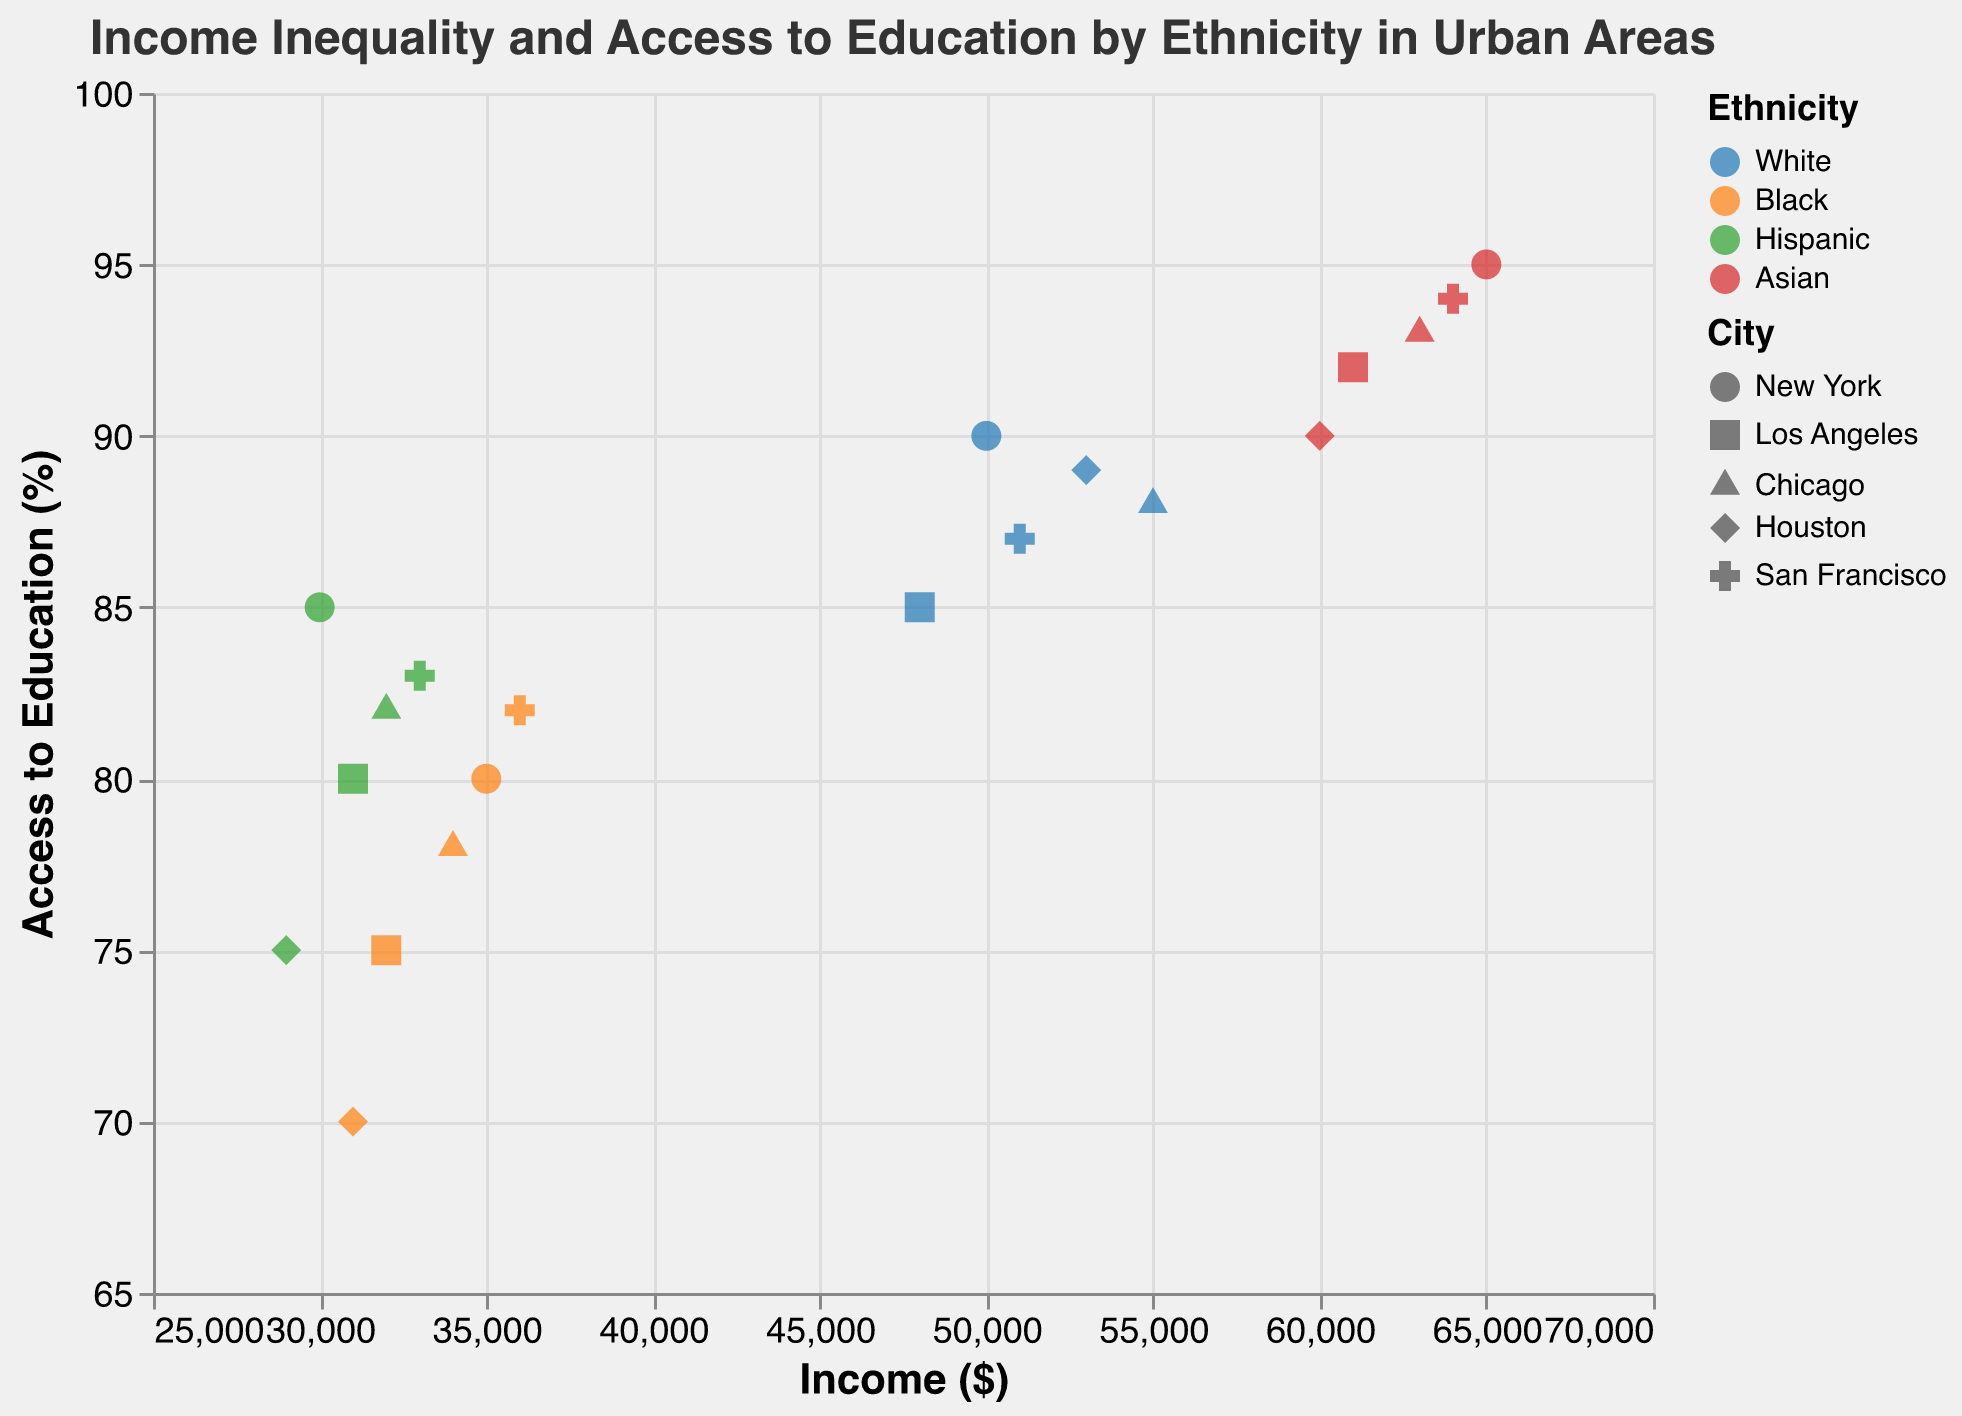What is the title of the figure? The title of the figure is usually displayed at the top and summarizes the content of the chart. By looking at the top of the figure, we can see the title.
Answer: Income Inequality and Access to Education by Ethnicity in Urban Areas How many data points are there in total? Each point on the scatter plot represents a data point. By counting all such points, we can determine the total number.
Answer: 20 Which ethnicity has the highest income in New York? To find this, look at the points representing different ethnicities in New York. Compare the income values on the X-axis to see which is the highest.
Answer: Asian What is the average Access to Education (%) for Black ethnicity across all cities? First, locate all points for Black ethnicity. Then, sum up their Access to Education (%) values and divide by the number of points (cities). Calculation: (80 + 75 + 78 + 70 + 82) / 5 = 77
Answer: 77 How does the Access to Education (%) for Hispanic ethnicity in Houston compare to San Francisco? Locate the points for Hispanic ethnicity in Houston and San Francisco. Compare their Access to Education (%) values on the Y-axis. In Houston, it's 75%, and in San Francisco, it's 83%.
Answer: San Francisco has higher Access to Education (%) Which city has the lowest Access to Education (%) for Black ethnicity? Identify the data points for Black ethnicity in each city. The point with the smallest Y-axis value represents the lowest Access to Education (%).
Answer: Houston What is the range of income for Hispanic ethnicity across all cities? Find the highest and lowest income values for Hispanic ethnicity by looking at their X-axis positions. The range is the difference between these values. Calculation: 33000 - 29000 = 4000
Answer: 4000 Does any ethnicity have perfect Access to Education (%)? Perfect Education Access would be 100%. Check all data points to see if any point reaches this value on the Y-axis.
Answer: No What is the difference in income between White ethnicity in Los Angeles and Chicago? Identify the income values for White ethnicity in Los Angeles and Chicago. Subtract the Los Angeles value from the Chicago value. Calculation: 55000 - 48000 = 7000
Answer: 7000 Which ethnicity has the highest average income across all cities? Calculate the average income for each ethnicity by summing their incomes and dividing by the number of cities (5). Compare these averages to determine the highest.
Answer: Asian 